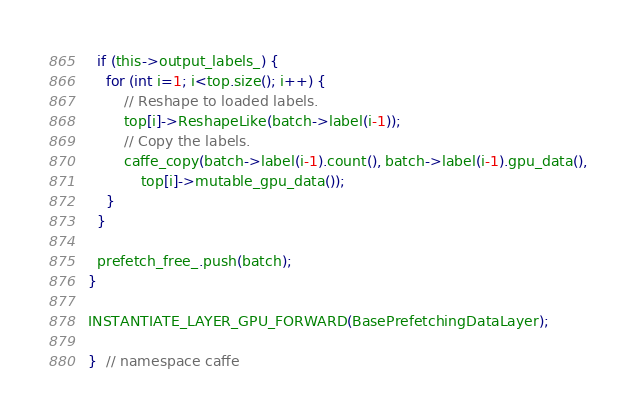Convert code to text. <code><loc_0><loc_0><loc_500><loc_500><_Cuda_>  if (this->output_labels_) {
    for (int i=1; i<top.size(); i++) {
        // Reshape to loaded labels.
        top[i]->ReshapeLike(batch->label(i-1));
        // Copy the labels.
        caffe_copy(batch->label(i-1).count(), batch->label(i-1).gpu_data(),
            top[i]->mutable_gpu_data());
    }
  }

  prefetch_free_.push(batch);
}

INSTANTIATE_LAYER_GPU_FORWARD(BasePrefetchingDataLayer);

}  // namespace caffe
</code> 